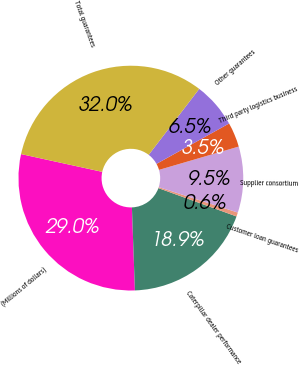<chart> <loc_0><loc_0><loc_500><loc_500><pie_chart><fcel>(Millions of dollars)<fcel>Caterpillar dealer performance<fcel>Customer loan guarantees<fcel>Supplier consortium<fcel>Third party logistics business<fcel>Other guarantees<fcel>Total guarantees<nl><fcel>29.01%<fcel>18.89%<fcel>0.58%<fcel>9.49%<fcel>3.55%<fcel>6.52%<fcel>31.98%<nl></chart> 